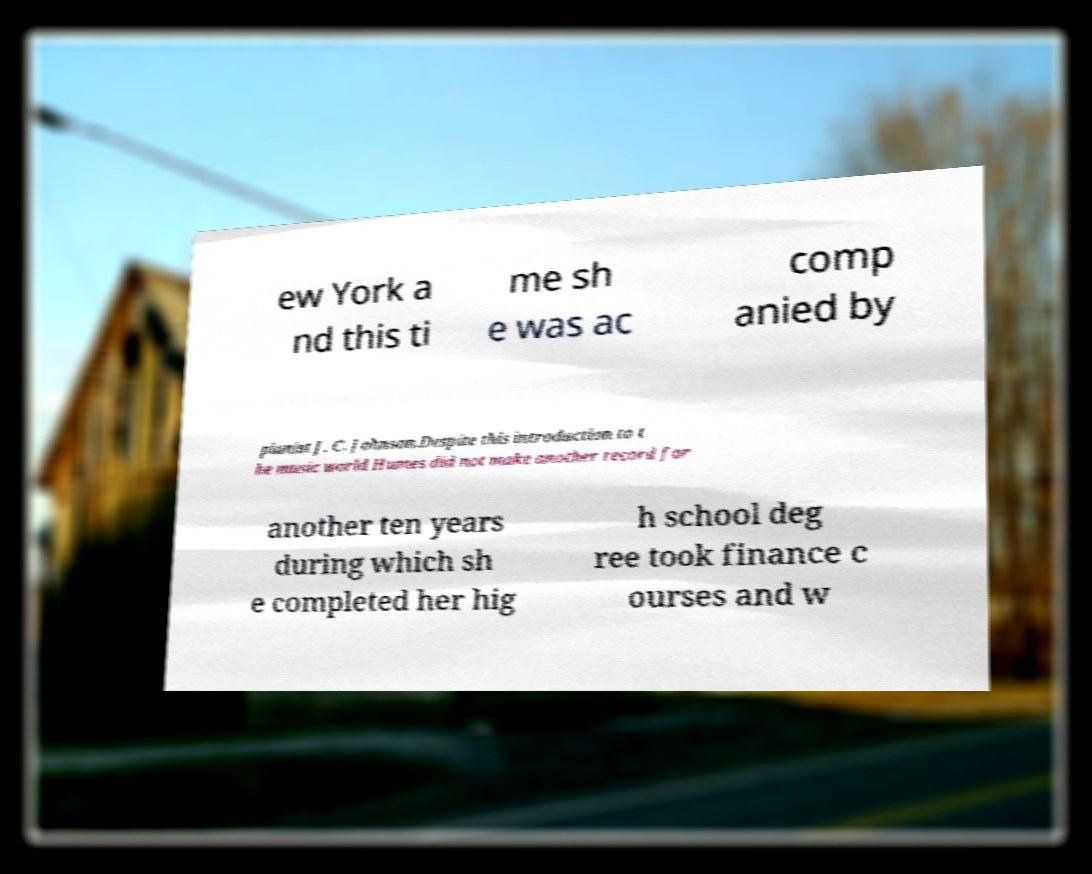For documentation purposes, I need the text within this image transcribed. Could you provide that? ew York a nd this ti me sh e was ac comp anied by pianist J. C. Johnson.Despite this introduction to t he music world Humes did not make another record for another ten years during which sh e completed her hig h school deg ree took finance c ourses and w 